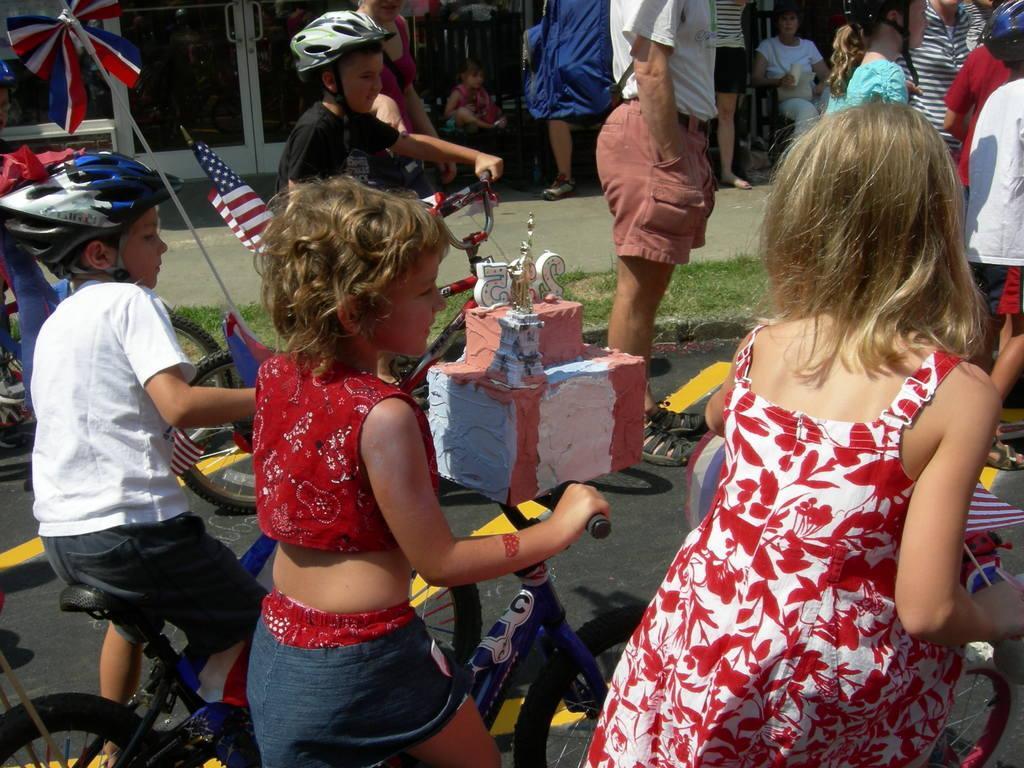Please provide a concise description of this image. As we can see in the image there are few people here and there. Among them four of them are sitting on bicycles. 